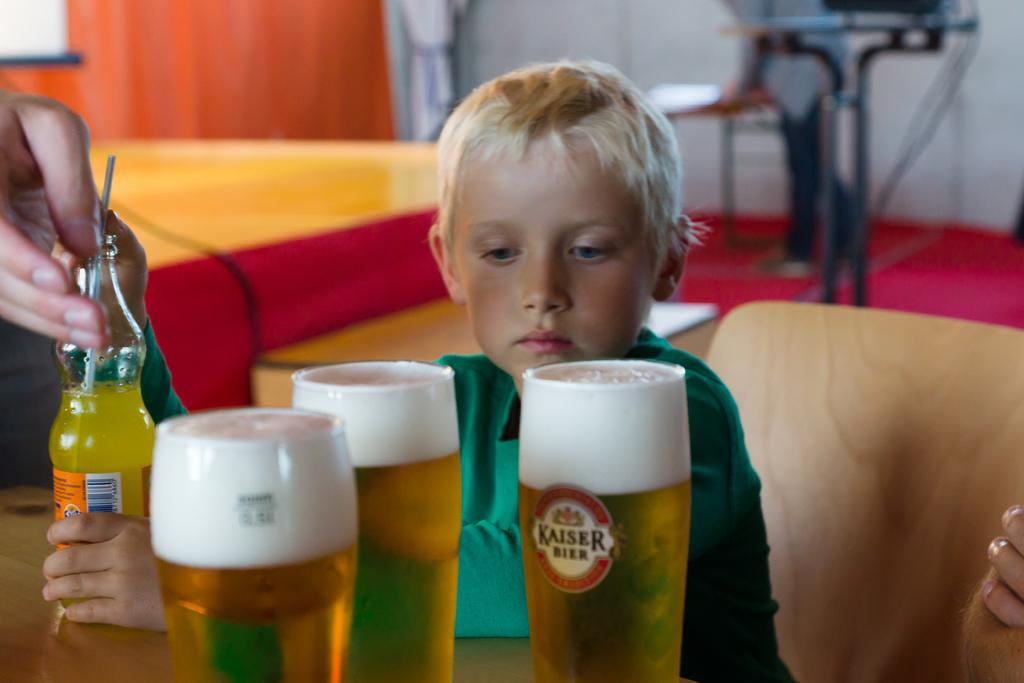<image>
Write a terse but informative summary of the picture. A boy is holding a bottle of juice and looking at three glasses of Kaiser beer. 